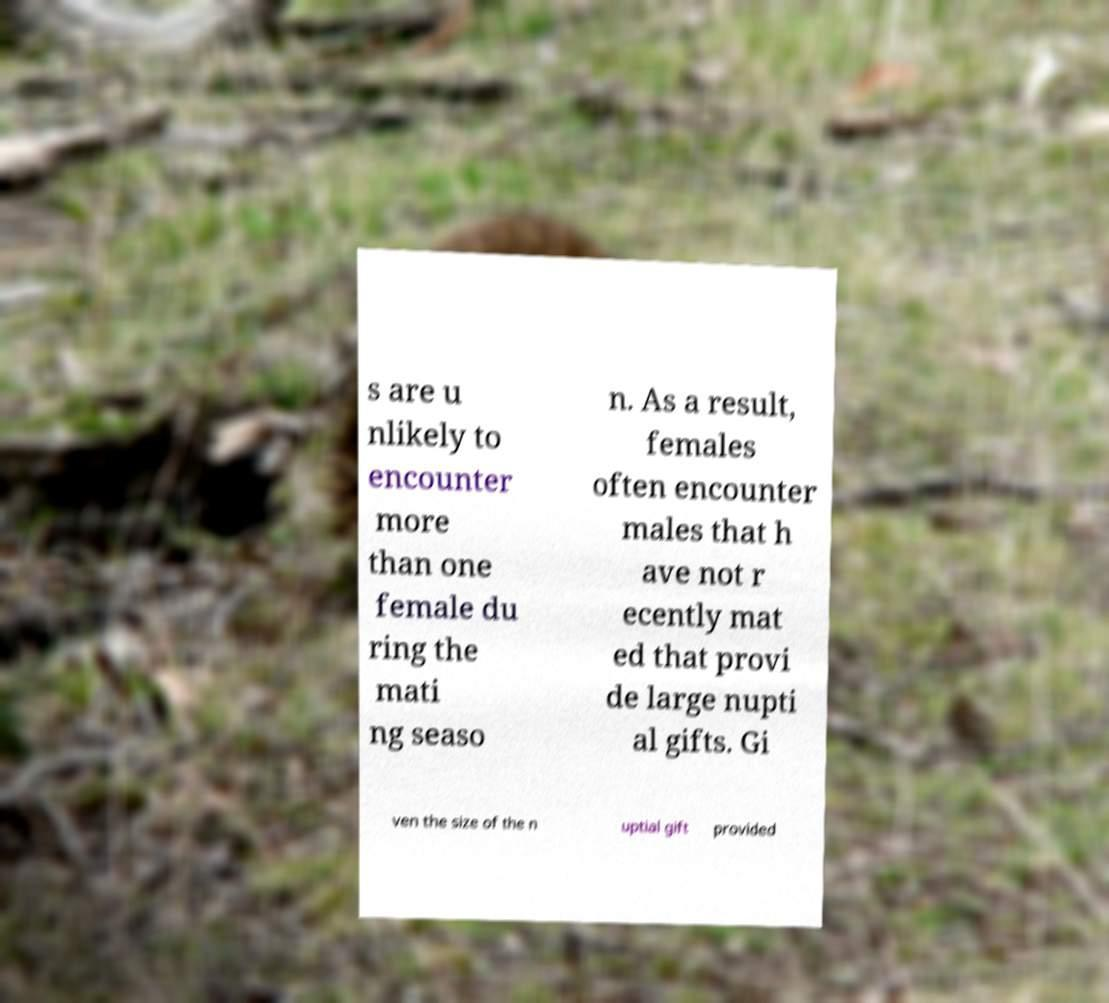Please read and relay the text visible in this image. What does it say? s are u nlikely to encounter more than one female du ring the mati ng seaso n. As a result, females often encounter males that h ave not r ecently mat ed that provi de large nupti al gifts. Gi ven the size of the n uptial gift provided 